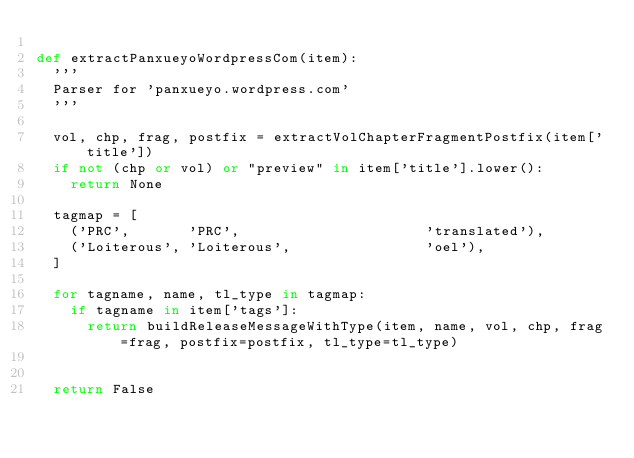<code> <loc_0><loc_0><loc_500><loc_500><_Python_>
def extractPanxueyoWordpressCom(item):
	'''
	Parser for 'panxueyo.wordpress.com'
	'''

	vol, chp, frag, postfix = extractVolChapterFragmentPostfix(item['title'])
	if not (chp or vol) or "preview" in item['title'].lower():
		return None

	tagmap = [
		('PRC',       'PRC',                      'translated'),
		('Loiterous', 'Loiterous',                'oel'),
	]

	for tagname, name, tl_type in tagmap:
		if tagname in item['tags']:
			return buildReleaseMessageWithType(item, name, vol, chp, frag=frag, postfix=postfix, tl_type=tl_type)


	return False
	</code> 